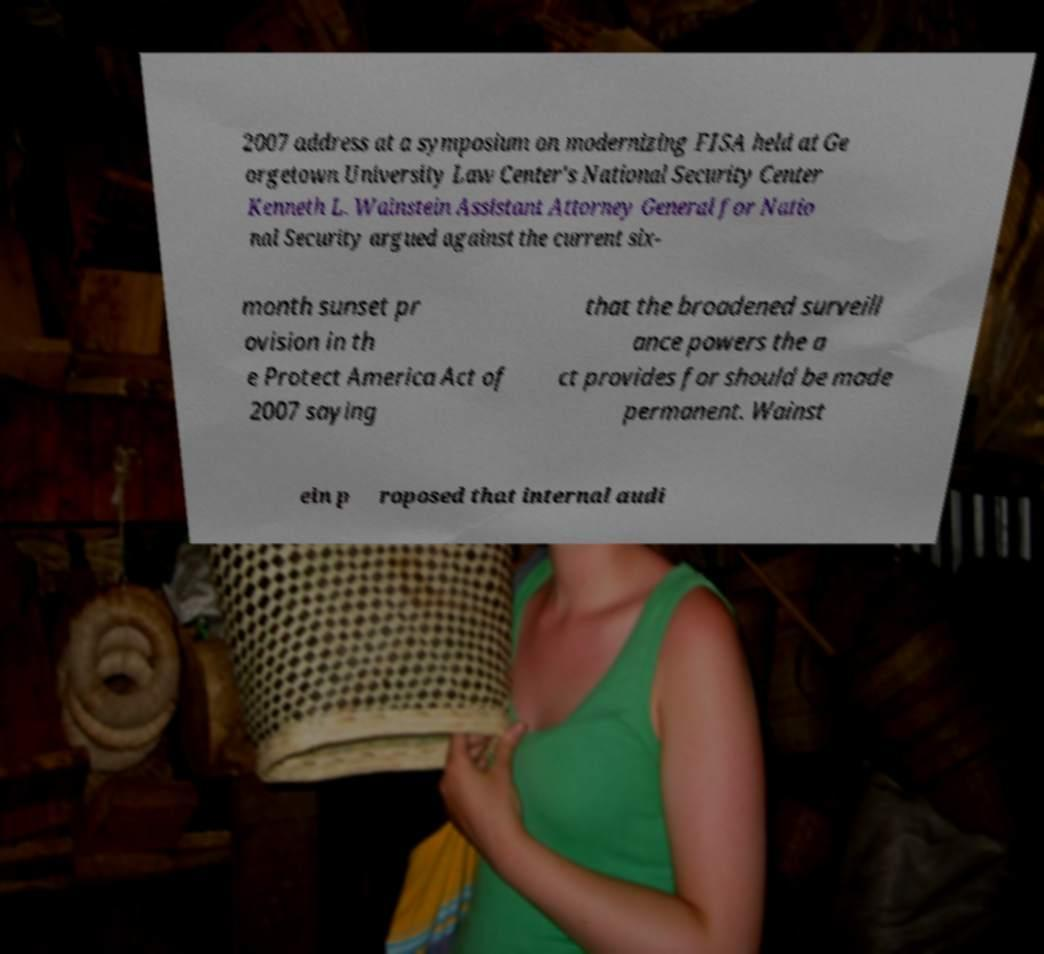Can you accurately transcribe the text from the provided image for me? 2007 address at a symposium on modernizing FISA held at Ge orgetown University Law Center's National Security Center Kenneth L. Wainstein Assistant Attorney General for Natio nal Security argued against the current six- month sunset pr ovision in th e Protect America Act of 2007 saying that the broadened surveill ance powers the a ct provides for should be made permanent. Wainst ein p roposed that internal audi 